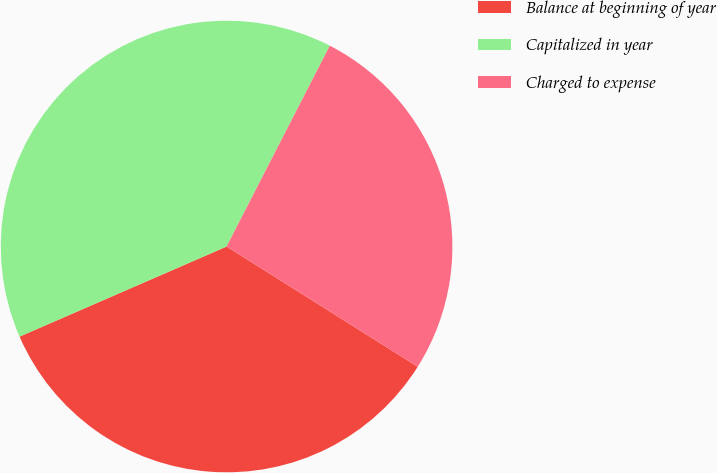Convert chart to OTSL. <chart><loc_0><loc_0><loc_500><loc_500><pie_chart><fcel>Balance at beginning of year<fcel>Capitalized in year<fcel>Charged to expense<nl><fcel>34.53%<fcel>39.09%<fcel>26.38%<nl></chart> 